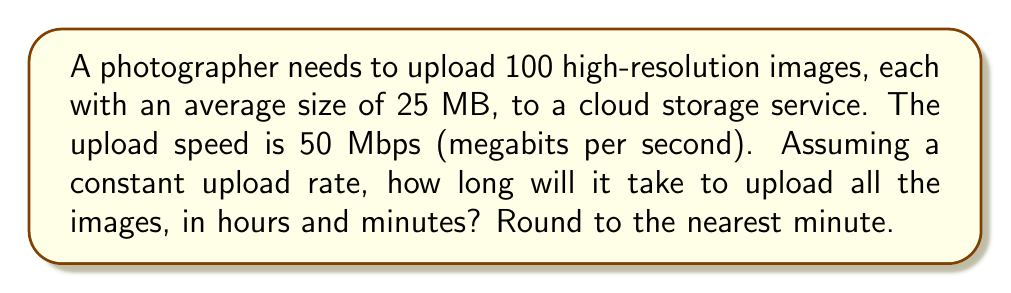Provide a solution to this math problem. Let's approach this step-by-step:

1) First, we need to calculate the total amount of data to be uploaded:
   $100 \text{ images} \times 25 \text{ MB/image} = 2500 \text{ MB} = 2.5 \text{ GB}$

2) Convert gigabytes (GB) to gigabits (Gb):
   $2.5 \text{ GB} \times 8 \text{ bits/byte} = 20 \text{ Gb}$

3) Calculate the time needed to upload:
   $\text{Time} = \frac{\text{Data to be uploaded}}{\text{Upload speed}}$
   
   $\text{Time} = \frac{20 \text{ Gb}}{50 \text{ Mbps}} = \frac{20,000 \text{ Mb}}{50 \text{ Mb/s}} = 400 \text{ seconds}$

4) Convert seconds to hours and minutes:
   $400 \text{ seconds} = \frac{400}{3600} \text{ hours} = 0.1111... \text{ hours}$
   
   $0.1111... \text{ hours} \times 60 \text{ minutes/hour} = 6.666... \text{ minutes}$

5) Rounding to the nearest minute:
   $6.666... \text{ minutes} \approx 7 \text{ minutes}$

Therefore, it will take approximately 0 hours and 7 minutes to upload all the images.
Answer: 0 hours and 7 minutes 